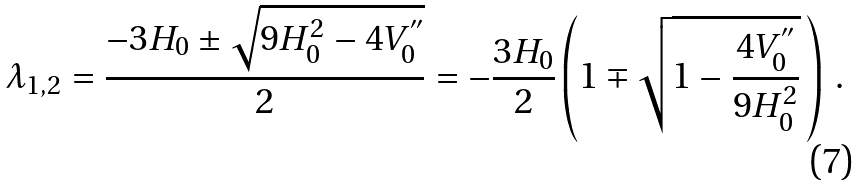Convert formula to latex. <formula><loc_0><loc_0><loc_500><loc_500>\lambda _ { 1 , 2 } = \frac { - 3 H _ { 0 } \pm \sqrt { 9 H _ { 0 } ^ { 2 } - 4 V _ { 0 } ^ { ^ { \prime \prime } } } } { 2 } = - \frac { 3 H _ { 0 } } { 2 } \left ( 1 \mp \sqrt { 1 - \frac { 4 V _ { 0 } ^ { ^ { \prime \prime } } } { 9 H _ { 0 } ^ { 2 } } } \, \right ) \, .</formula> 